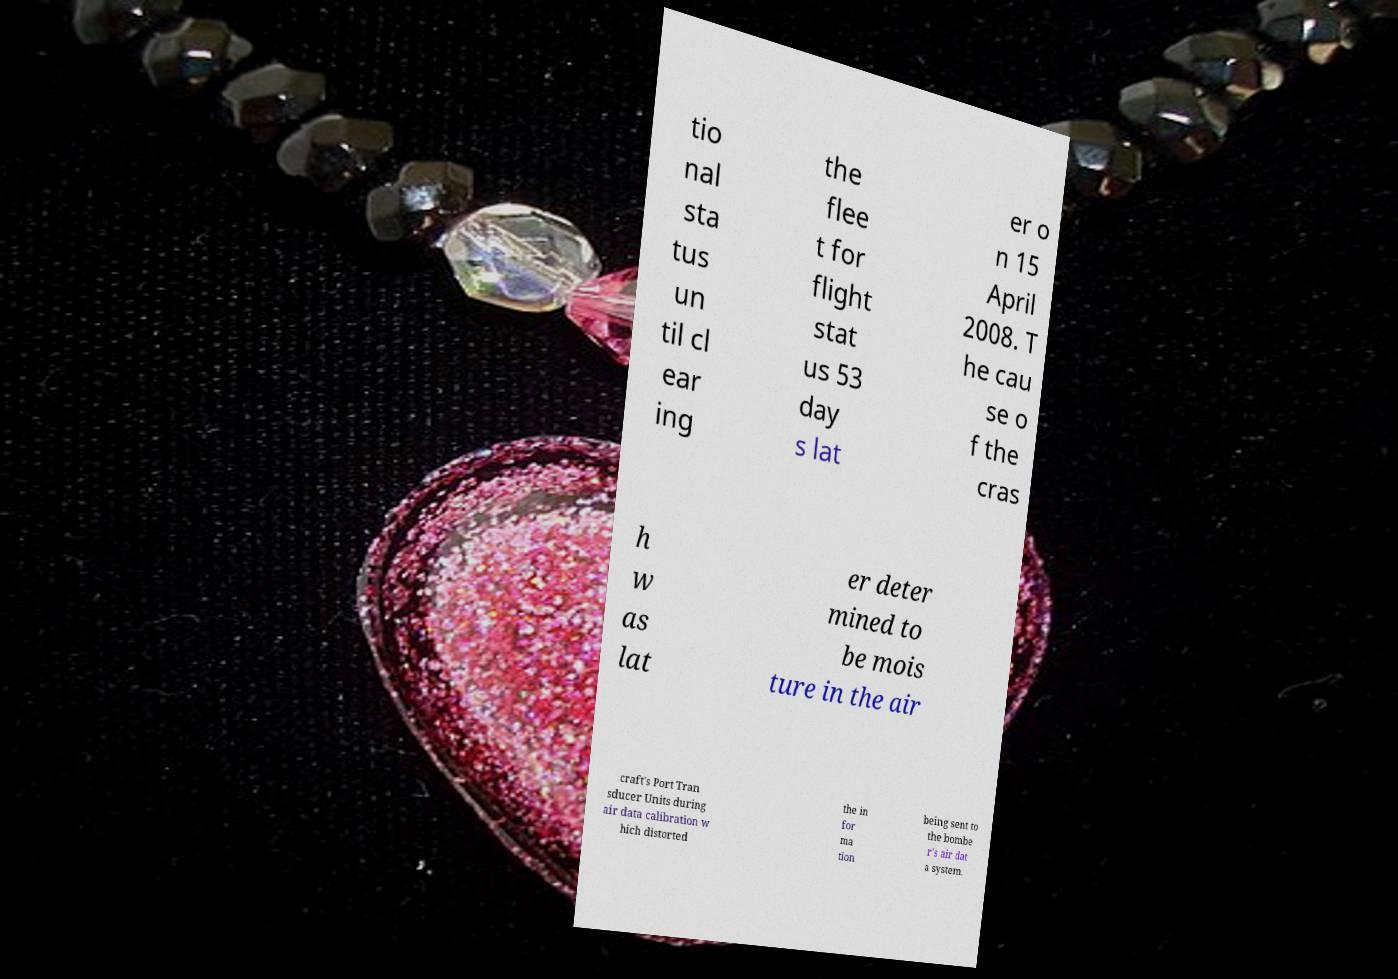What messages or text are displayed in this image? I need them in a readable, typed format. tio nal sta tus un til cl ear ing the flee t for flight stat us 53 day s lat er o n 15 April 2008. T he cau se o f the cras h w as lat er deter mined to be mois ture in the air craft's Port Tran sducer Units during air data calibration w hich distorted the in for ma tion being sent to the bombe r's air dat a system. 